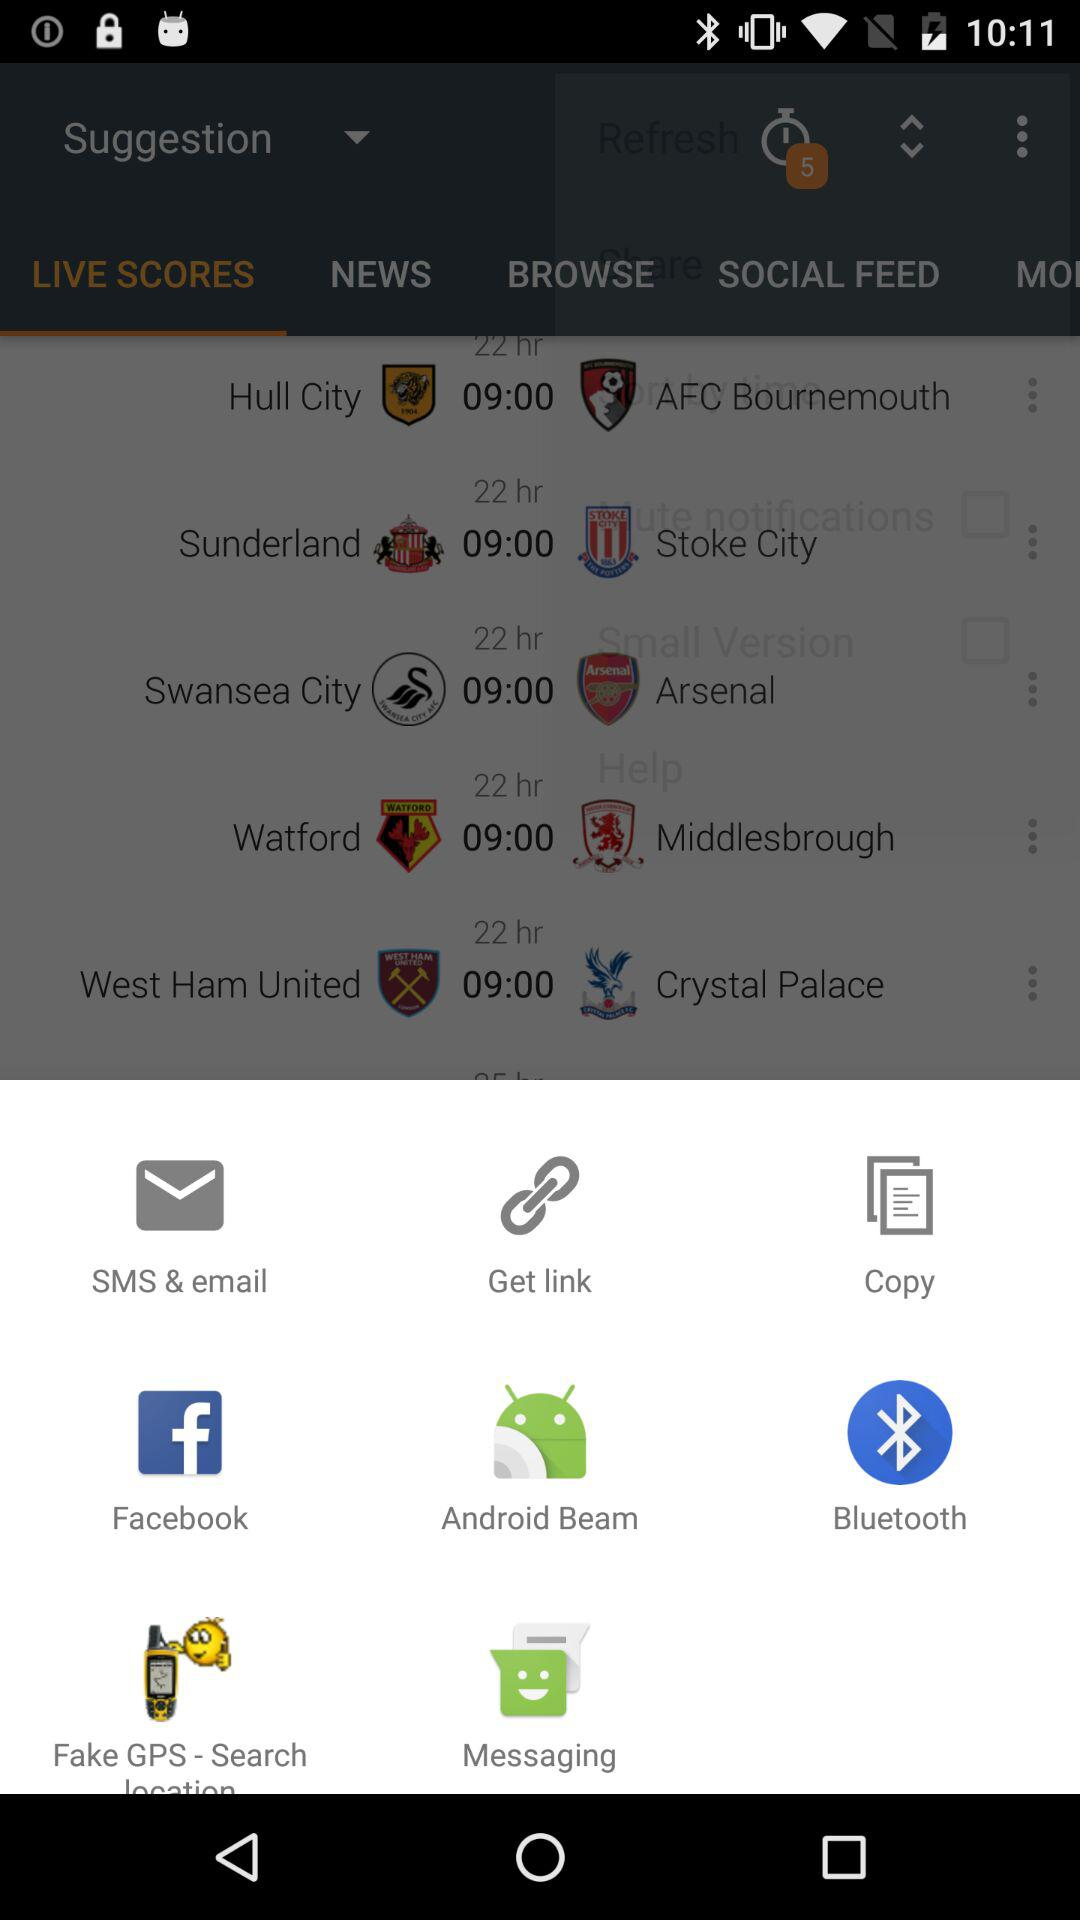Which are the different applications mentioned there? The different mentioned applications are "Facebook", "Android Beam", "Bluetooth", "Fake GPS - Search location" and "Messaging". 